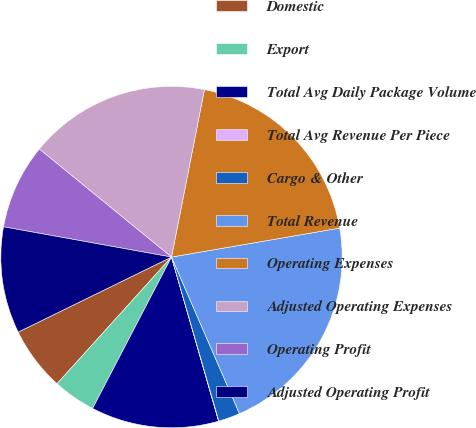<chart> <loc_0><loc_0><loc_500><loc_500><pie_chart><fcel>Domestic<fcel>Export<fcel>Total Avg Daily Package Volume<fcel>Total Avg Revenue Per Piece<fcel>Cargo & Other<fcel>Total Revenue<fcel>Operating Expenses<fcel>Adjusted Operating Expenses<fcel>Operating Profit<fcel>Adjusted Operating Profit<nl><fcel>6.06%<fcel>4.05%<fcel>12.09%<fcel>0.03%<fcel>2.04%<fcel>21.2%<fcel>19.19%<fcel>17.18%<fcel>8.07%<fcel>10.08%<nl></chart> 